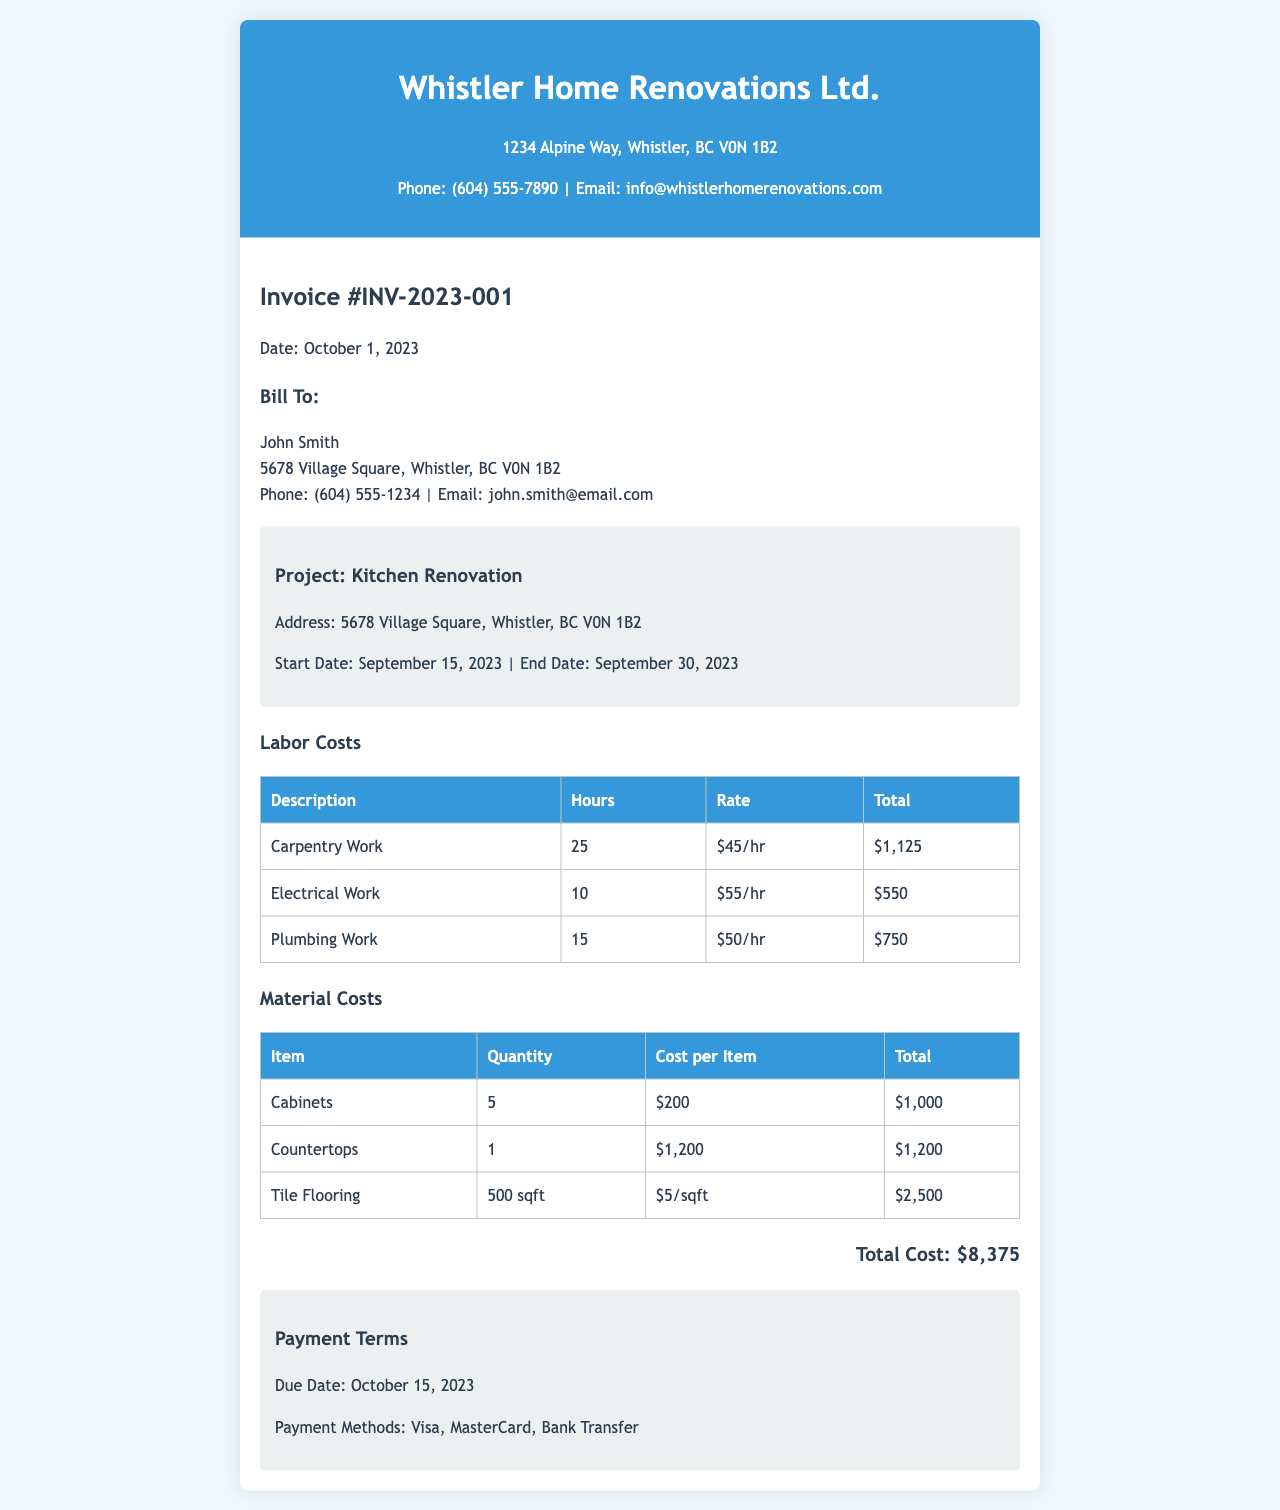What is the invoice number? The invoice number is listed in the document as Invoice #INV-2023-001.
Answer: Invoice #INV-2023-001 What is the total cost of the renovation project? The total cost can be found in the document's total section, which states Total Cost: $8,375.
Answer: $8,375 Who is the client for this renovation project? The client's name is mentioned in the billing section as John Smith.
Answer: John Smith What is the start date of the renovation project? The start date is provided in the project information section as September 15, 2023.
Answer: September 15, 2023 How many hours were spent on carpentry work? The hours for carpentry work are specified in the labor costs table, listing 25 hours.
Answer: 25 What is the due date for the payment? The due date is stated in the payment information section as October 15, 2023.
Answer: October 15, 2023 What type of project is this invoice for? The project type is indicated in the project information section as Kitchen Renovation.
Answer: Kitchen Renovation How much was spent on tile flooring? The amount spent on tile flooring is detailed in the material costs section, listing $2,500 as the total.
Answer: $2,500 What payment methods are accepted? The document specifies that payment methods listed are Visa, MasterCard, and Bank Transfer.
Answer: Visa, MasterCard, Bank Transfer 